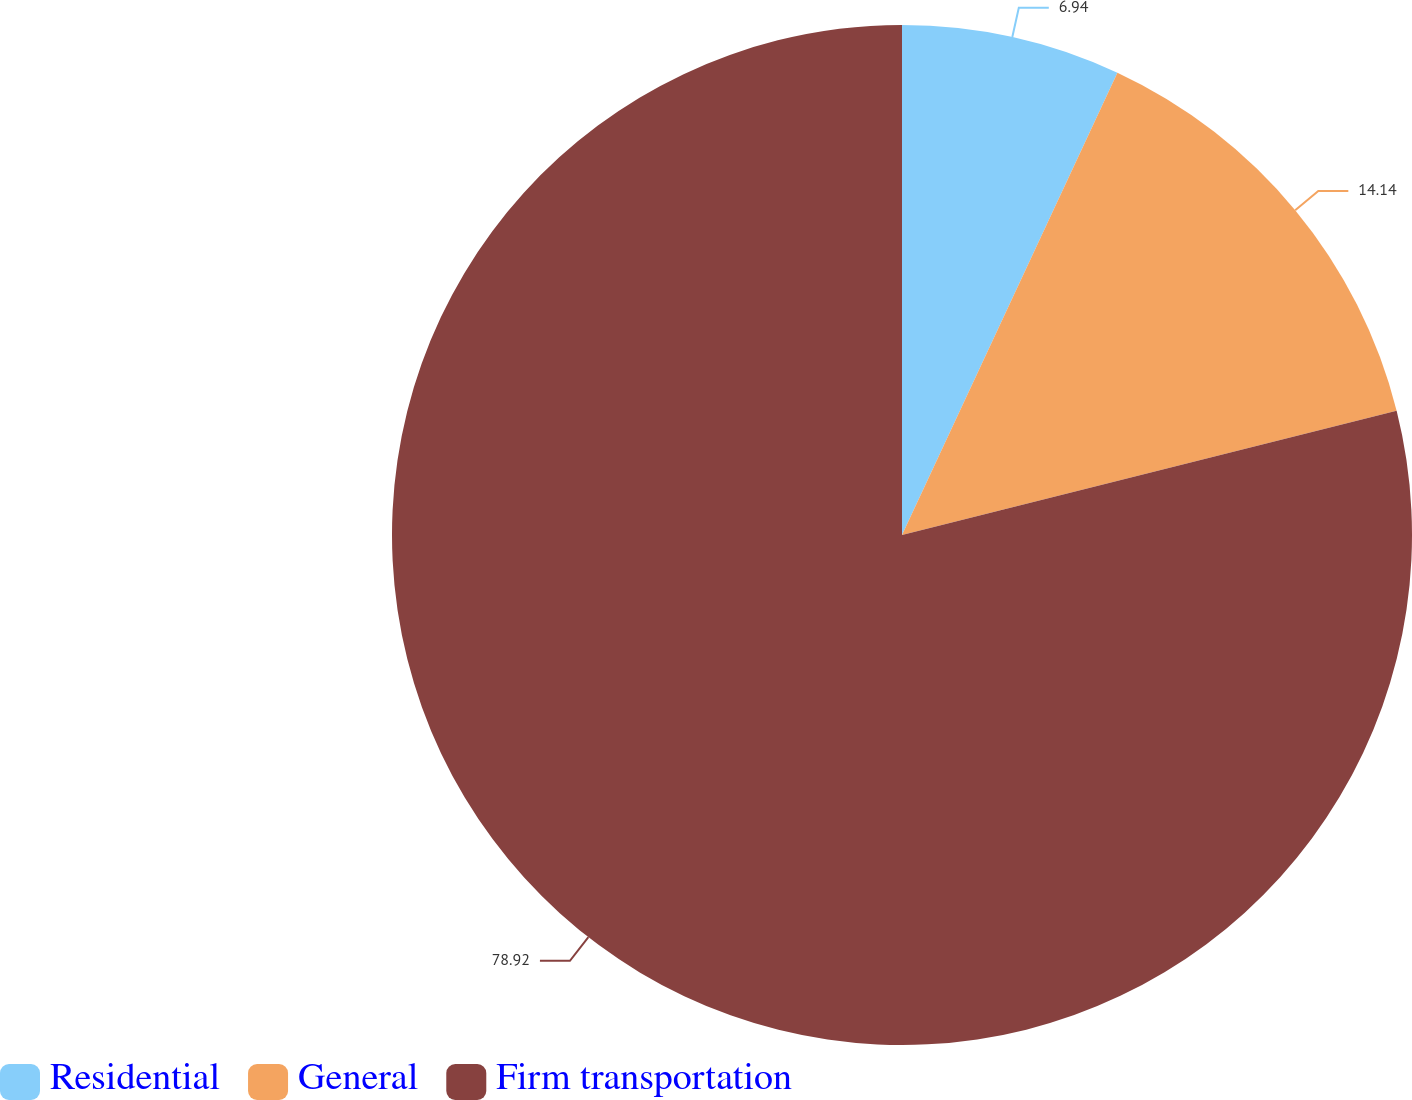Convert chart to OTSL. <chart><loc_0><loc_0><loc_500><loc_500><pie_chart><fcel>Residential<fcel>General<fcel>Firm transportation<nl><fcel>6.94%<fcel>14.14%<fcel>78.91%<nl></chart> 